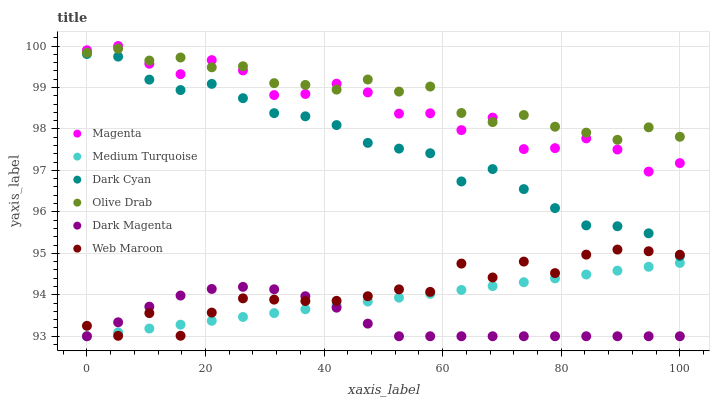Does Dark Magenta have the minimum area under the curve?
Answer yes or no. Yes. Does Olive Drab have the maximum area under the curve?
Answer yes or no. Yes. Does Web Maroon have the minimum area under the curve?
Answer yes or no. No. Does Web Maroon have the maximum area under the curve?
Answer yes or no. No. Is Medium Turquoise the smoothest?
Answer yes or no. Yes. Is Magenta the roughest?
Answer yes or no. Yes. Is Web Maroon the smoothest?
Answer yes or no. No. Is Web Maroon the roughest?
Answer yes or no. No. Does Dark Magenta have the lowest value?
Answer yes or no. Yes. Does Web Maroon have the lowest value?
Answer yes or no. No. Does Magenta have the highest value?
Answer yes or no. Yes. Does Web Maroon have the highest value?
Answer yes or no. No. Is Web Maroon less than Olive Drab?
Answer yes or no. Yes. Is Olive Drab greater than Dark Cyan?
Answer yes or no. Yes. Does Dark Magenta intersect Web Maroon?
Answer yes or no. Yes. Is Dark Magenta less than Web Maroon?
Answer yes or no. No. Is Dark Magenta greater than Web Maroon?
Answer yes or no. No. Does Web Maroon intersect Olive Drab?
Answer yes or no. No. 